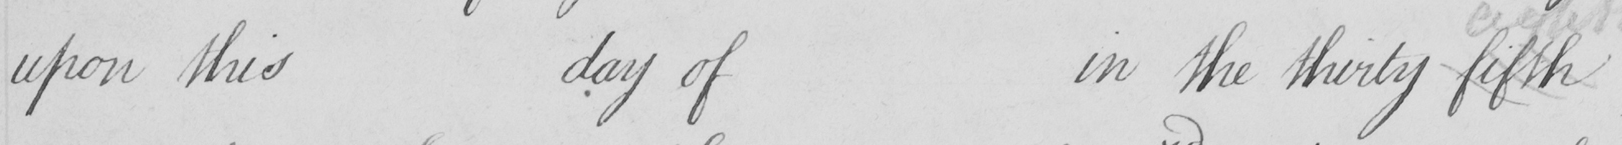What does this handwritten line say? upon this day of in the thirty fifth 